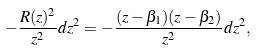Convert formula to latex. <formula><loc_0><loc_0><loc_500><loc_500>- \frac { R ( z ) ^ { 2 } } { z ^ { 2 } } d z ^ { 2 } = - \frac { ( z - \beta _ { 1 } ) ( z - \beta _ { 2 } ) } { z ^ { 2 } } d z ^ { 2 } ,</formula> 